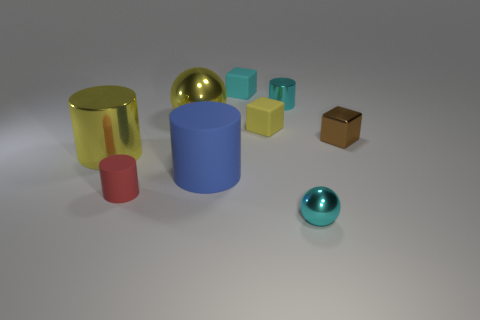Is the number of blue cylinders in front of the tiny red matte cylinder greater than the number of small purple shiny balls?
Your answer should be compact. No. Are any large cyan rubber spheres visible?
Provide a succinct answer. No. What number of yellow cylinders have the same size as the yellow shiny sphere?
Keep it short and to the point. 1. Is the number of big yellow metallic balls that are in front of the cyan rubber block greater than the number of large blue cylinders behind the yellow cylinder?
Ensure brevity in your answer.  Yes. There is a red cylinder that is the same size as the brown cube; what is its material?
Give a very brief answer. Rubber. The red thing is what shape?
Provide a short and direct response. Cylinder. How many yellow objects are either blocks or big objects?
Offer a terse response. 3. What is the size of the yellow cylinder that is the same material as the big yellow sphere?
Give a very brief answer. Large. Do the ball left of the small sphere and the small cylinder right of the small yellow block have the same material?
Make the answer very short. Yes. What number of balls are either brown rubber objects or shiny objects?
Your answer should be very brief. 2. 